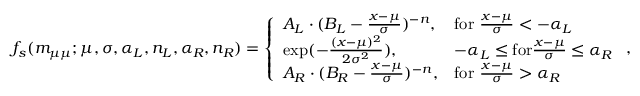<formula> <loc_0><loc_0><loc_500><loc_500>f _ { s } ( { m _ { \mu \mu } } ; \mu , \sigma , \alpha _ { L } , n _ { L } , \alpha _ { R } , n _ { R } ) = \left \{ \begin{array} { l l } { A _ { L } \cdot ( B _ { L } - \frac { x - \mu } { \sigma } ) ^ { - n } , } & { f o r \frac { x - \mu } { \sigma } < - \alpha _ { L } } \\ { \exp ( - \frac { ( x - \mu ) ^ { 2 } } { 2 \sigma ^ { 2 } } ) , } & { - \alpha _ { L } \leq f o r \frac { x - \mu } { \sigma } \leq \alpha _ { R } } \\ { A _ { R } \cdot ( B _ { R } - \frac { x - \mu } { \sigma } ) ^ { - n } , } & { f o r \frac { x - \mu } { \sigma } > \alpha _ { R } } \end{array} ,</formula> 